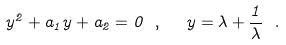Convert formula to latex. <formula><loc_0><loc_0><loc_500><loc_500>y ^ { 2 } + a _ { 1 } y + a _ { 2 } = 0 \ , \ \ y = \lambda + \frac { 1 } { \lambda } \ .</formula> 